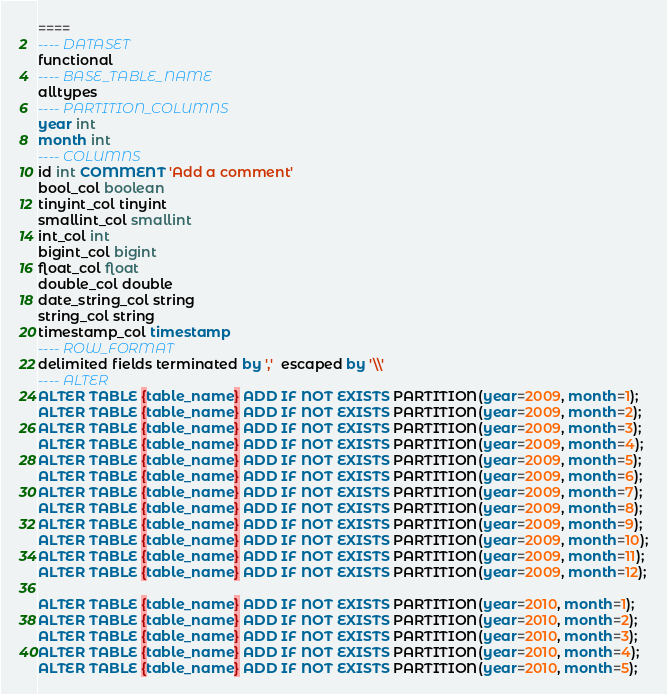Convert code to text. <code><loc_0><loc_0><loc_500><loc_500><_SQL_>====
---- DATASET
functional
---- BASE_TABLE_NAME
alltypes
---- PARTITION_COLUMNS
year int
month int
---- COLUMNS
id int COMMENT 'Add a comment'
bool_col boolean
tinyint_col tinyint
smallint_col smallint
int_col int
bigint_col bigint
float_col float
double_col double
date_string_col string
string_col string
timestamp_col timestamp
---- ROW_FORMAT
delimited fields terminated by ','  escaped by '\\'
---- ALTER
ALTER TABLE {table_name} ADD IF NOT EXISTS PARTITION(year=2009, month=1);
ALTER TABLE {table_name} ADD IF NOT EXISTS PARTITION(year=2009, month=2);
ALTER TABLE {table_name} ADD IF NOT EXISTS PARTITION(year=2009, month=3);
ALTER TABLE {table_name} ADD IF NOT EXISTS PARTITION(year=2009, month=4);
ALTER TABLE {table_name} ADD IF NOT EXISTS PARTITION(year=2009, month=5);
ALTER TABLE {table_name} ADD IF NOT EXISTS PARTITION(year=2009, month=6);
ALTER TABLE {table_name} ADD IF NOT EXISTS PARTITION(year=2009, month=7);
ALTER TABLE {table_name} ADD IF NOT EXISTS PARTITION(year=2009, month=8);
ALTER TABLE {table_name} ADD IF NOT EXISTS PARTITION(year=2009, month=9);
ALTER TABLE {table_name} ADD IF NOT EXISTS PARTITION(year=2009, month=10);
ALTER TABLE {table_name} ADD IF NOT EXISTS PARTITION(year=2009, month=11);
ALTER TABLE {table_name} ADD IF NOT EXISTS PARTITION(year=2009, month=12);

ALTER TABLE {table_name} ADD IF NOT EXISTS PARTITION(year=2010, month=1);
ALTER TABLE {table_name} ADD IF NOT EXISTS PARTITION(year=2010, month=2);
ALTER TABLE {table_name} ADD IF NOT EXISTS PARTITION(year=2010, month=3);
ALTER TABLE {table_name} ADD IF NOT EXISTS PARTITION(year=2010, month=4);
ALTER TABLE {table_name} ADD IF NOT EXISTS PARTITION(year=2010, month=5);</code> 